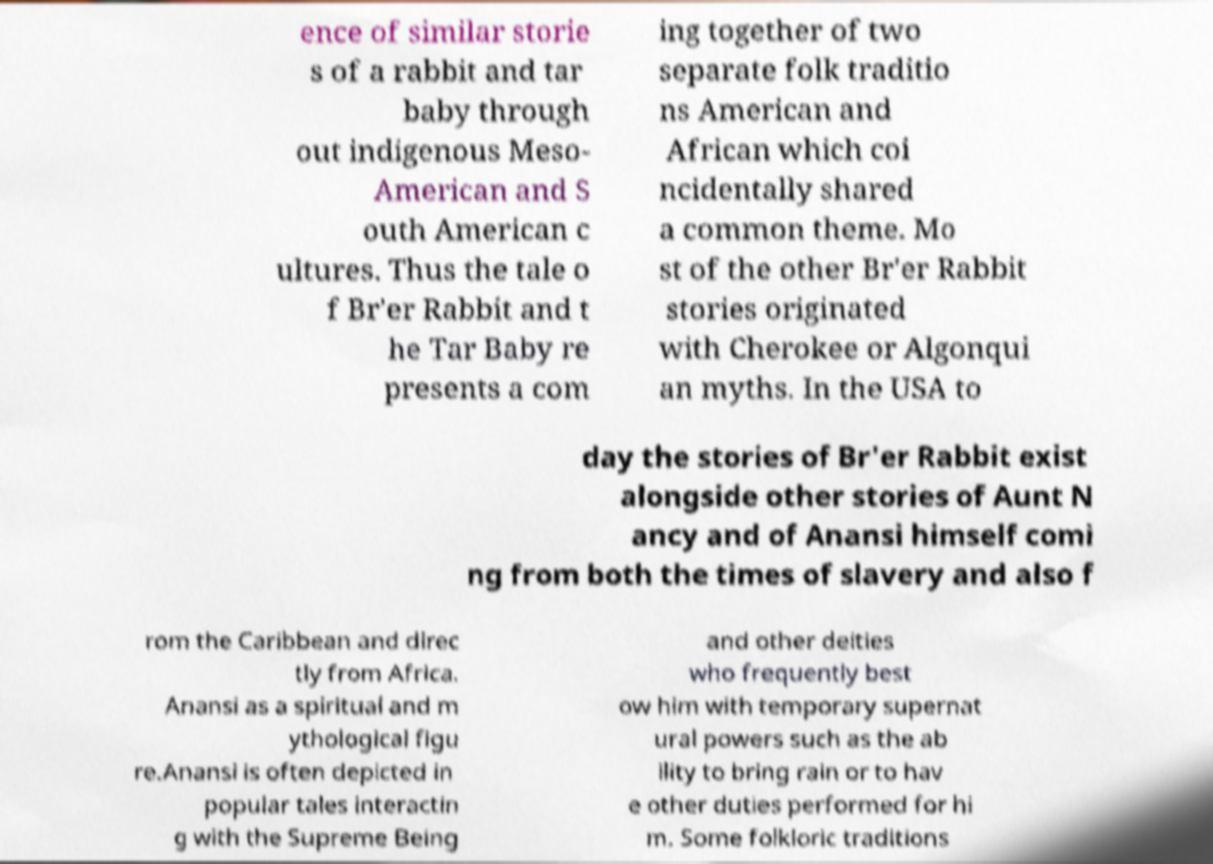Can you accurately transcribe the text from the provided image for me? ence of similar storie s of a rabbit and tar baby through out indigenous Meso- American and S outh American c ultures. Thus the tale o f Br'er Rabbit and t he Tar Baby re presents a com ing together of two separate folk traditio ns American and African which coi ncidentally shared a common theme. Mo st of the other Br'er Rabbit stories originated with Cherokee or Algonqui an myths. In the USA to day the stories of Br'er Rabbit exist alongside other stories of Aunt N ancy and of Anansi himself comi ng from both the times of slavery and also f rom the Caribbean and direc tly from Africa. Anansi as a spiritual and m ythological figu re.Anansi is often depicted in popular tales interactin g with the Supreme Being and other deities who frequently best ow him with temporary supernat ural powers such as the ab ility to bring rain or to hav e other duties performed for hi m. Some folkloric traditions 